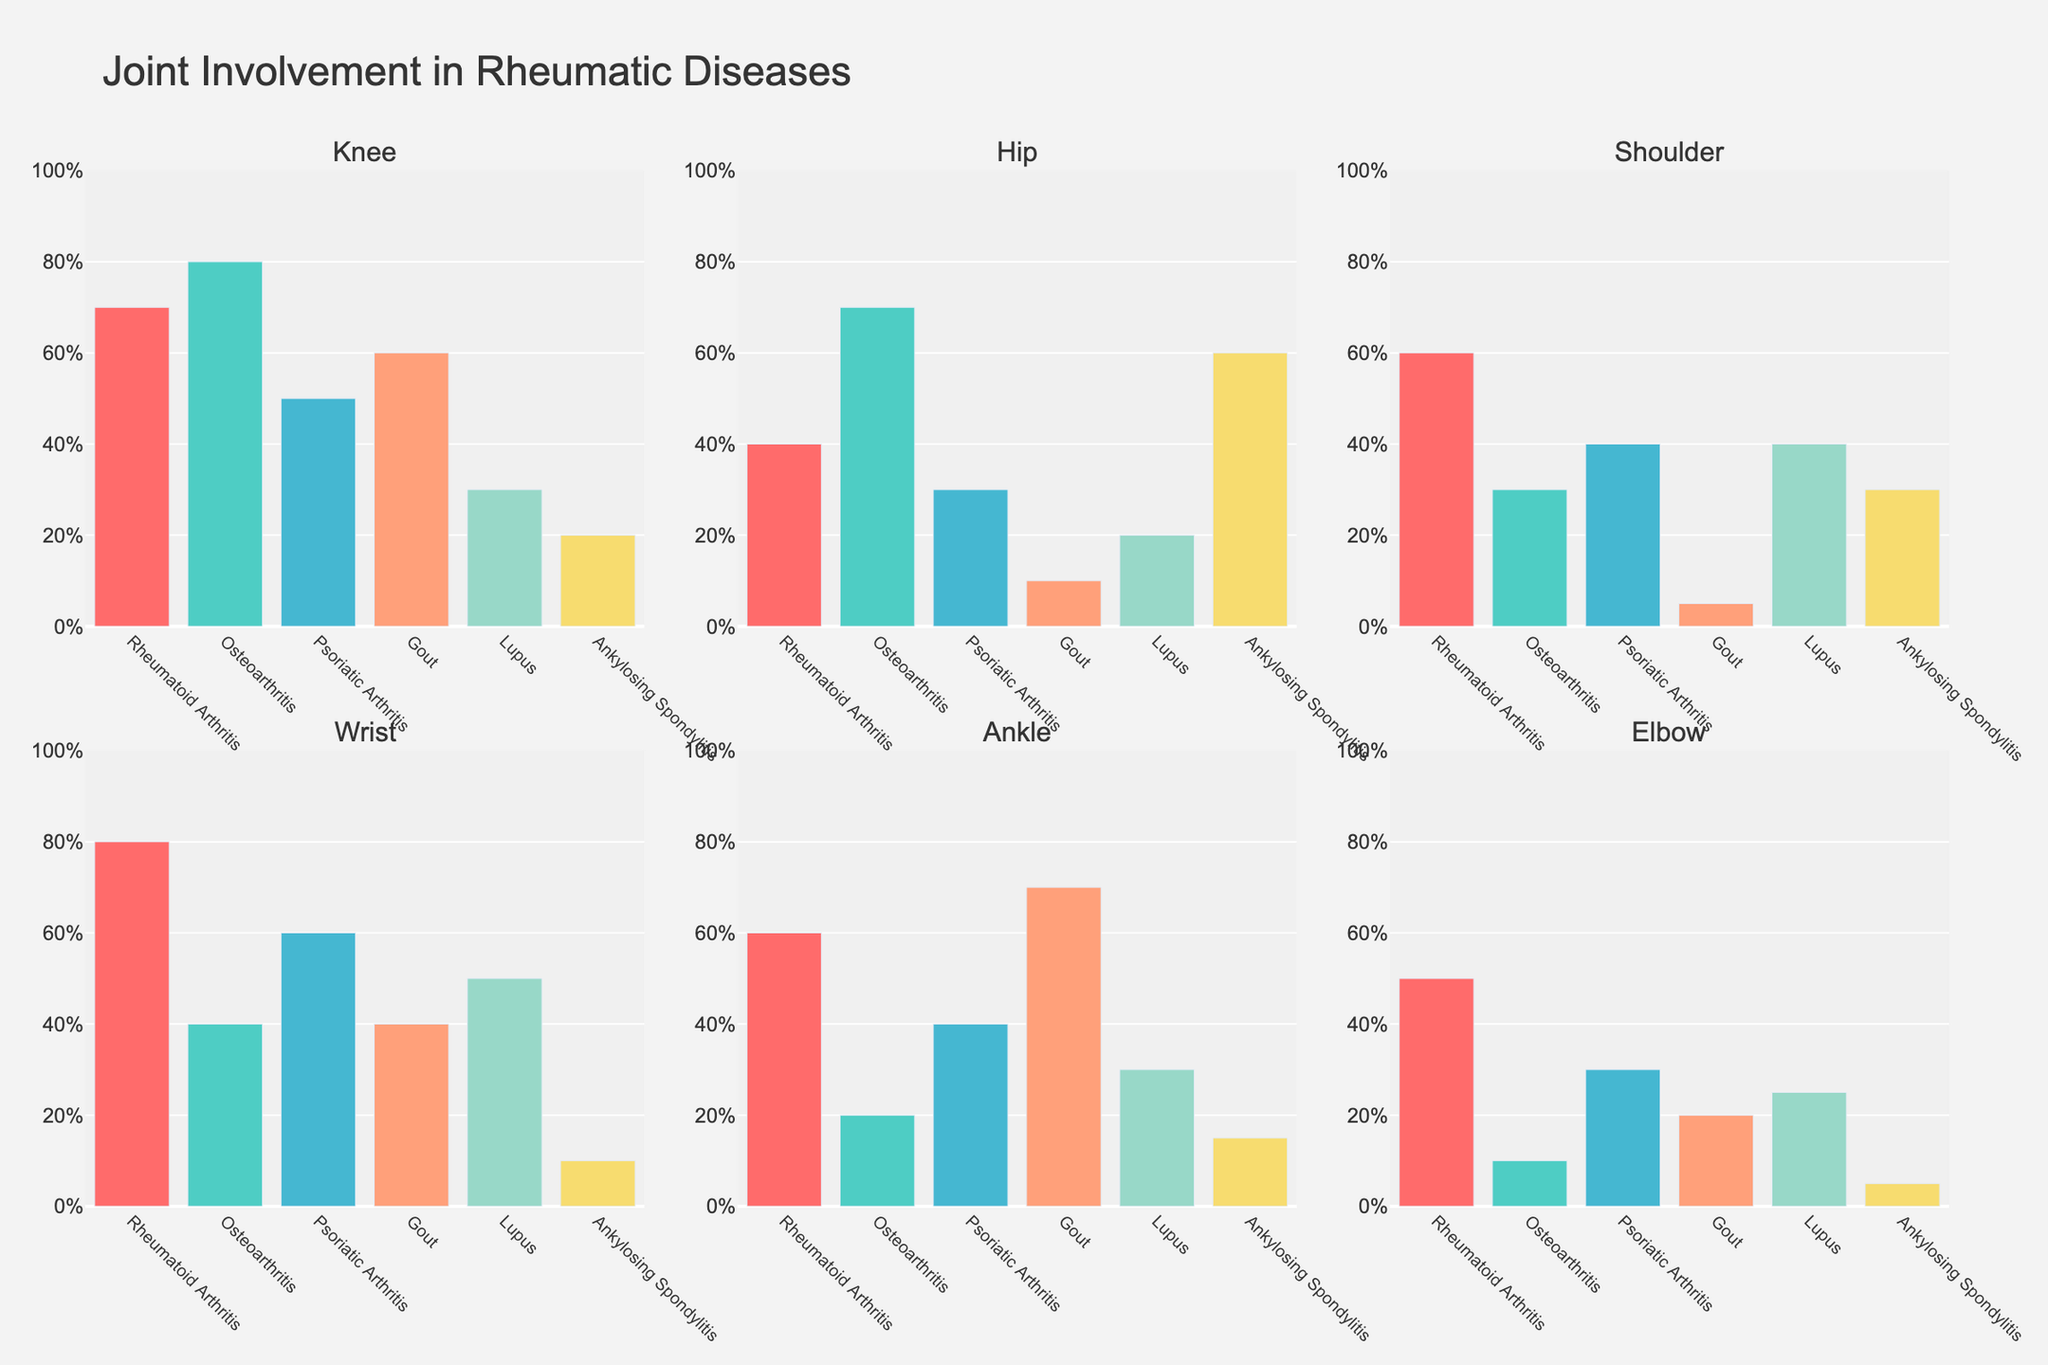What is the title of the figure? The title of the figure is prominently displayed at the top center.
Answer: "Joint Involvement in Rheumatic Diseases" Which joint has the highest involvement in Osteoarthritis? By examining the subplot for Osteoarthritis, the knee joint has the highest bar, which means the highest involvement.
Answer: Knee What disease shows the most frequency in shoulder involvement? By looking at the height of the bars in the shoulder's subplot, Rheumatoid Arthritis has the highest bar indicating it has the most frequency.
Answer: Rheumatoid Arthritis Which joints have more than 50% involvement in Rheumatoid Arthritis? In the subplot rows/columns, look for Rheumatoid Arthritis bars: Knee (70%), Shoulder (60%), Wrist (80%), Ankle (60%), and Elbow (50%).
Answer: Knee, Shoulder, Wrist, Ankle, Elbow What is the least involved joint in Gout? Check the subplots for the smallest height bars in Gout's category. The shoulder joint has the smallest (5%).
Answer: Shoulder How many diseases have wrist involvement greater than 40%? Look at the heights of the wrist bars; Rheumatoid Arthritis (80%) and Psoriatic Arthritis (60%) both exceed 40%.
Answer: 2 Which disease has the greatest range of involvement percentages across all joints? Calculate the difference between the highest and lowest values in each disease category: 
- Rheumatoid Arthritis: 80-40=40
- Osteoarthritis: 80-10=70
- Psoriatic Arthritis: 60-30=30
- Gout: 70-5=65
- Lupus: 50-20=30
- Ankylosing Spondylitis: 60-5=55. 
Osteoarthritis has the greatest range of 70.
Answer: Osteoarthritis Compare the differences in knee involvement between Rheumatoid Arthritis and Ankylosing Spondylitis. Subtract the involvement percentages for the knee joint of each disease: Rheumatoid Arthritis (70%) - Ankylosing Spondylitis (20%) = 50%.
Answer: 50% What is the average involvement of the elbow joint across all diseases? Sum the involvement percentages for the elbow joint: 50 + 10 + 30 + 20 + 25 + 5 = 140. Number of diseases = 6. Average = 140 / 6 ≈ 23.3%.
Answer: 23.3% Which disease shows an equal percentage of involvement in any two joints? By closely examining each disease’s involvement percentages, Gout has equal involvement in the knee (60%) and ankle (60%).
Answer: Gout 